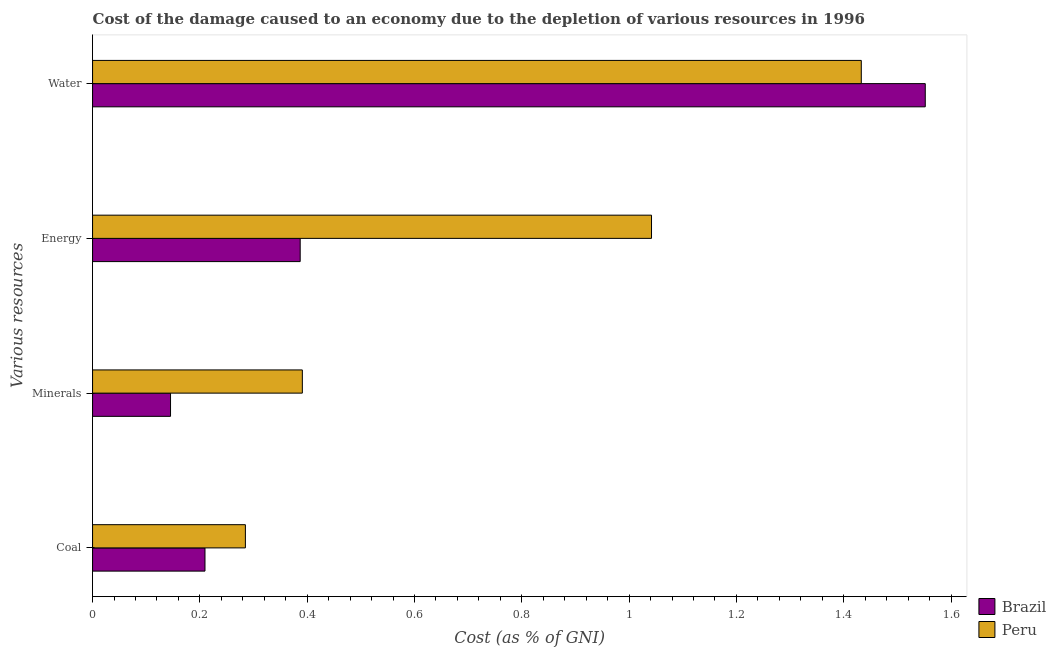Are the number of bars on each tick of the Y-axis equal?
Offer a very short reply. Yes. How many bars are there on the 1st tick from the bottom?
Your answer should be compact. 2. What is the label of the 2nd group of bars from the top?
Ensure brevity in your answer.  Energy. What is the cost of damage due to depletion of minerals in Peru?
Your response must be concise. 0.39. Across all countries, what is the maximum cost of damage due to depletion of coal?
Your answer should be very brief. 0.28. Across all countries, what is the minimum cost of damage due to depletion of energy?
Give a very brief answer. 0.39. What is the total cost of damage due to depletion of energy in the graph?
Ensure brevity in your answer.  1.43. What is the difference between the cost of damage due to depletion of coal in Peru and that in Brazil?
Offer a very short reply. 0.08. What is the difference between the cost of damage due to depletion of minerals in Brazil and the cost of damage due to depletion of water in Peru?
Your answer should be very brief. -1.29. What is the average cost of damage due to depletion of energy per country?
Provide a succinct answer. 0.71. What is the difference between the cost of damage due to depletion of minerals and cost of damage due to depletion of coal in Brazil?
Offer a very short reply. -0.06. What is the ratio of the cost of damage due to depletion of energy in Peru to that in Brazil?
Provide a succinct answer. 2.69. What is the difference between the highest and the second highest cost of damage due to depletion of water?
Offer a very short reply. 0.12. What is the difference between the highest and the lowest cost of damage due to depletion of water?
Your answer should be very brief. 0.12. Is it the case that in every country, the sum of the cost of damage due to depletion of coal and cost of damage due to depletion of energy is greater than the sum of cost of damage due to depletion of minerals and cost of damage due to depletion of water?
Provide a succinct answer. Yes. What does the 1st bar from the top in Water represents?
Provide a succinct answer. Peru. What does the 2nd bar from the bottom in Energy represents?
Keep it short and to the point. Peru. Is it the case that in every country, the sum of the cost of damage due to depletion of coal and cost of damage due to depletion of minerals is greater than the cost of damage due to depletion of energy?
Your answer should be very brief. No. Are all the bars in the graph horizontal?
Ensure brevity in your answer.  Yes. What is the difference between two consecutive major ticks on the X-axis?
Your response must be concise. 0.2. Does the graph contain any zero values?
Provide a short and direct response. No. What is the title of the graph?
Keep it short and to the point. Cost of the damage caused to an economy due to the depletion of various resources in 1996 . What is the label or title of the X-axis?
Offer a terse response. Cost (as % of GNI). What is the label or title of the Y-axis?
Give a very brief answer. Various resources. What is the Cost (as % of GNI) in Brazil in Coal?
Your response must be concise. 0.21. What is the Cost (as % of GNI) of Peru in Coal?
Provide a short and direct response. 0.28. What is the Cost (as % of GNI) of Brazil in Minerals?
Provide a succinct answer. 0.15. What is the Cost (as % of GNI) of Peru in Minerals?
Your answer should be compact. 0.39. What is the Cost (as % of GNI) in Brazil in Energy?
Offer a very short reply. 0.39. What is the Cost (as % of GNI) of Peru in Energy?
Provide a short and direct response. 1.04. What is the Cost (as % of GNI) of Brazil in Water?
Your response must be concise. 1.55. What is the Cost (as % of GNI) in Peru in Water?
Your answer should be compact. 1.43. Across all Various resources, what is the maximum Cost (as % of GNI) in Brazil?
Ensure brevity in your answer.  1.55. Across all Various resources, what is the maximum Cost (as % of GNI) in Peru?
Keep it short and to the point. 1.43. Across all Various resources, what is the minimum Cost (as % of GNI) in Brazil?
Your answer should be compact. 0.15. Across all Various resources, what is the minimum Cost (as % of GNI) in Peru?
Your response must be concise. 0.28. What is the total Cost (as % of GNI) in Brazil in the graph?
Make the answer very short. 2.29. What is the total Cost (as % of GNI) in Peru in the graph?
Provide a succinct answer. 3.15. What is the difference between the Cost (as % of GNI) in Brazil in Coal and that in Minerals?
Give a very brief answer. 0.06. What is the difference between the Cost (as % of GNI) of Peru in Coal and that in Minerals?
Offer a very short reply. -0.11. What is the difference between the Cost (as % of GNI) in Brazil in Coal and that in Energy?
Your response must be concise. -0.18. What is the difference between the Cost (as % of GNI) in Peru in Coal and that in Energy?
Ensure brevity in your answer.  -0.76. What is the difference between the Cost (as % of GNI) of Brazil in Coal and that in Water?
Your response must be concise. -1.34. What is the difference between the Cost (as % of GNI) of Peru in Coal and that in Water?
Your answer should be compact. -1.15. What is the difference between the Cost (as % of GNI) of Brazil in Minerals and that in Energy?
Ensure brevity in your answer.  -0.24. What is the difference between the Cost (as % of GNI) of Peru in Minerals and that in Energy?
Your answer should be compact. -0.65. What is the difference between the Cost (as % of GNI) in Brazil in Minerals and that in Water?
Offer a terse response. -1.41. What is the difference between the Cost (as % of GNI) in Peru in Minerals and that in Water?
Make the answer very short. -1.04. What is the difference between the Cost (as % of GNI) in Brazil in Energy and that in Water?
Your answer should be compact. -1.16. What is the difference between the Cost (as % of GNI) in Peru in Energy and that in Water?
Your answer should be compact. -0.39. What is the difference between the Cost (as % of GNI) in Brazil in Coal and the Cost (as % of GNI) in Peru in Minerals?
Your answer should be compact. -0.18. What is the difference between the Cost (as % of GNI) of Brazil in Coal and the Cost (as % of GNI) of Peru in Energy?
Keep it short and to the point. -0.83. What is the difference between the Cost (as % of GNI) of Brazil in Coal and the Cost (as % of GNI) of Peru in Water?
Offer a very short reply. -1.22. What is the difference between the Cost (as % of GNI) in Brazil in Minerals and the Cost (as % of GNI) in Peru in Energy?
Offer a terse response. -0.9. What is the difference between the Cost (as % of GNI) of Brazil in Minerals and the Cost (as % of GNI) of Peru in Water?
Provide a short and direct response. -1.29. What is the difference between the Cost (as % of GNI) in Brazil in Energy and the Cost (as % of GNI) in Peru in Water?
Provide a succinct answer. -1.05. What is the average Cost (as % of GNI) in Brazil per Various resources?
Give a very brief answer. 0.57. What is the average Cost (as % of GNI) of Peru per Various resources?
Your answer should be very brief. 0.79. What is the difference between the Cost (as % of GNI) of Brazil and Cost (as % of GNI) of Peru in Coal?
Make the answer very short. -0.08. What is the difference between the Cost (as % of GNI) of Brazil and Cost (as % of GNI) of Peru in Minerals?
Ensure brevity in your answer.  -0.25. What is the difference between the Cost (as % of GNI) of Brazil and Cost (as % of GNI) of Peru in Energy?
Your answer should be compact. -0.65. What is the difference between the Cost (as % of GNI) of Brazil and Cost (as % of GNI) of Peru in Water?
Offer a very short reply. 0.12. What is the ratio of the Cost (as % of GNI) in Brazil in Coal to that in Minerals?
Give a very brief answer. 1.44. What is the ratio of the Cost (as % of GNI) in Peru in Coal to that in Minerals?
Offer a very short reply. 0.73. What is the ratio of the Cost (as % of GNI) in Brazil in Coal to that in Energy?
Provide a short and direct response. 0.54. What is the ratio of the Cost (as % of GNI) in Peru in Coal to that in Energy?
Provide a succinct answer. 0.27. What is the ratio of the Cost (as % of GNI) of Brazil in Coal to that in Water?
Provide a succinct answer. 0.14. What is the ratio of the Cost (as % of GNI) of Peru in Coal to that in Water?
Offer a terse response. 0.2. What is the ratio of the Cost (as % of GNI) in Brazil in Minerals to that in Energy?
Provide a short and direct response. 0.38. What is the ratio of the Cost (as % of GNI) of Peru in Minerals to that in Energy?
Make the answer very short. 0.38. What is the ratio of the Cost (as % of GNI) of Brazil in Minerals to that in Water?
Make the answer very short. 0.09. What is the ratio of the Cost (as % of GNI) in Peru in Minerals to that in Water?
Ensure brevity in your answer.  0.27. What is the ratio of the Cost (as % of GNI) of Brazil in Energy to that in Water?
Your answer should be very brief. 0.25. What is the ratio of the Cost (as % of GNI) of Peru in Energy to that in Water?
Provide a short and direct response. 0.73. What is the difference between the highest and the second highest Cost (as % of GNI) in Brazil?
Offer a terse response. 1.16. What is the difference between the highest and the second highest Cost (as % of GNI) of Peru?
Give a very brief answer. 0.39. What is the difference between the highest and the lowest Cost (as % of GNI) of Brazil?
Offer a very short reply. 1.41. What is the difference between the highest and the lowest Cost (as % of GNI) in Peru?
Offer a very short reply. 1.15. 